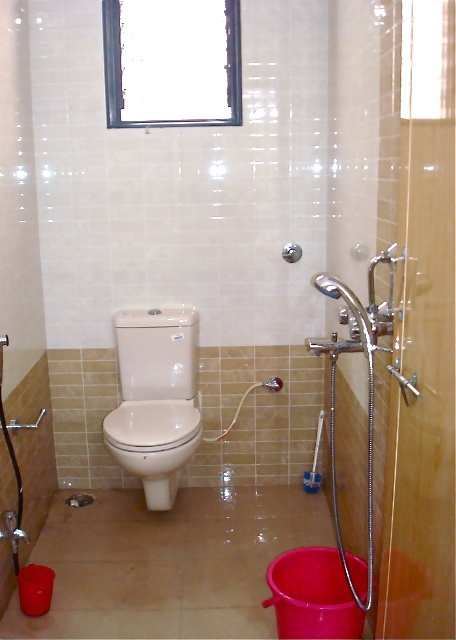Describe the objects in this image and their specific colors. I can see a toilet in pink, darkgray, and lightgray tones in this image. 